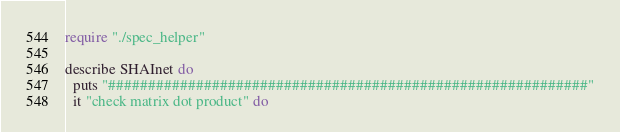Convert code to text. <code><loc_0><loc_0><loc_500><loc_500><_Crystal_>require "./spec_helper"

describe SHAInet do
  puts "############################################################"
  it "check matrix dot product" do</code> 